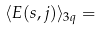Convert formula to latex. <formula><loc_0><loc_0><loc_500><loc_500>\langle E ( s , j ) \rangle _ { 3 q } =</formula> 